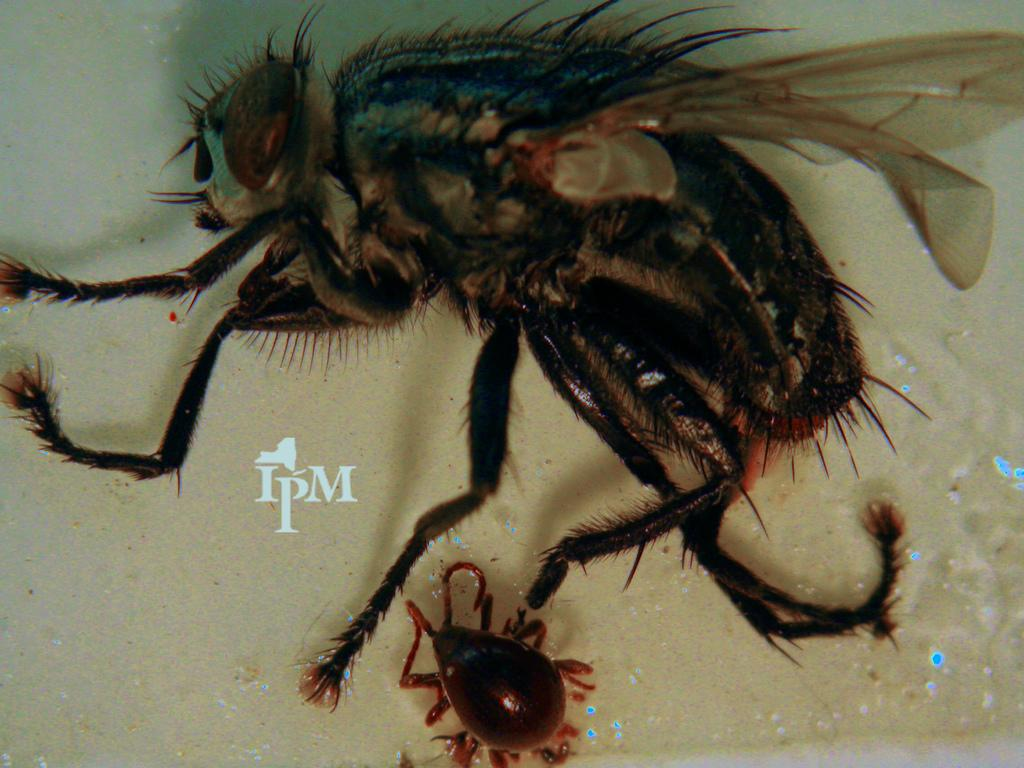What type of insect is present in the image? There is a housefly in the image. Where is the insect located in the image? The insect is at the bottom of the image. What type of key is hanging from the cobweb in the image? There is no key or cobweb present in the image; it only features a housefly. Where can you find the market in the image? There is no market present in the image. 